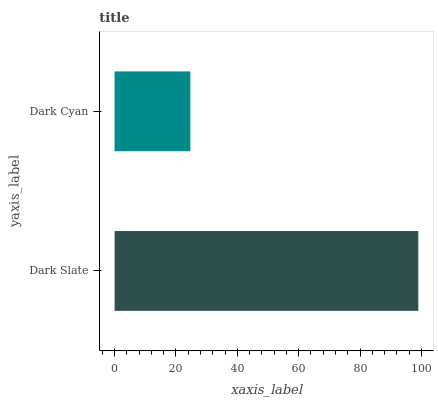Is Dark Cyan the minimum?
Answer yes or no. Yes. Is Dark Slate the maximum?
Answer yes or no. Yes. Is Dark Cyan the maximum?
Answer yes or no. No. Is Dark Slate greater than Dark Cyan?
Answer yes or no. Yes. Is Dark Cyan less than Dark Slate?
Answer yes or no. Yes. Is Dark Cyan greater than Dark Slate?
Answer yes or no. No. Is Dark Slate less than Dark Cyan?
Answer yes or no. No. Is Dark Slate the high median?
Answer yes or no. Yes. Is Dark Cyan the low median?
Answer yes or no. Yes. Is Dark Cyan the high median?
Answer yes or no. No. Is Dark Slate the low median?
Answer yes or no. No. 